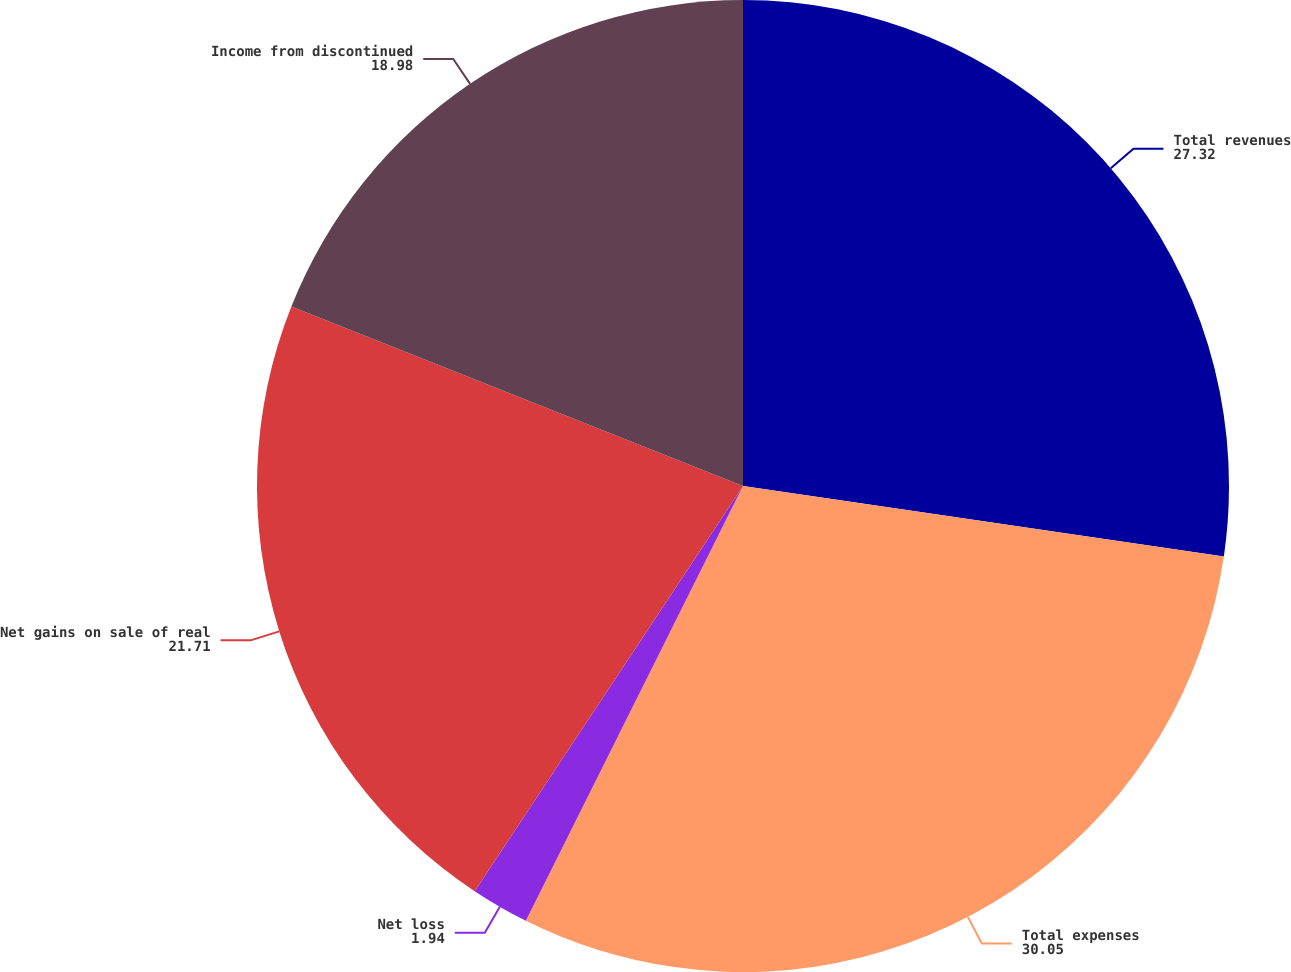Convert chart. <chart><loc_0><loc_0><loc_500><loc_500><pie_chart><fcel>Total revenues<fcel>Total expenses<fcel>Net loss<fcel>Net gains on sale of real<fcel>Income from discontinued<nl><fcel>27.32%<fcel>30.05%<fcel>1.94%<fcel>21.71%<fcel>18.98%<nl></chart> 